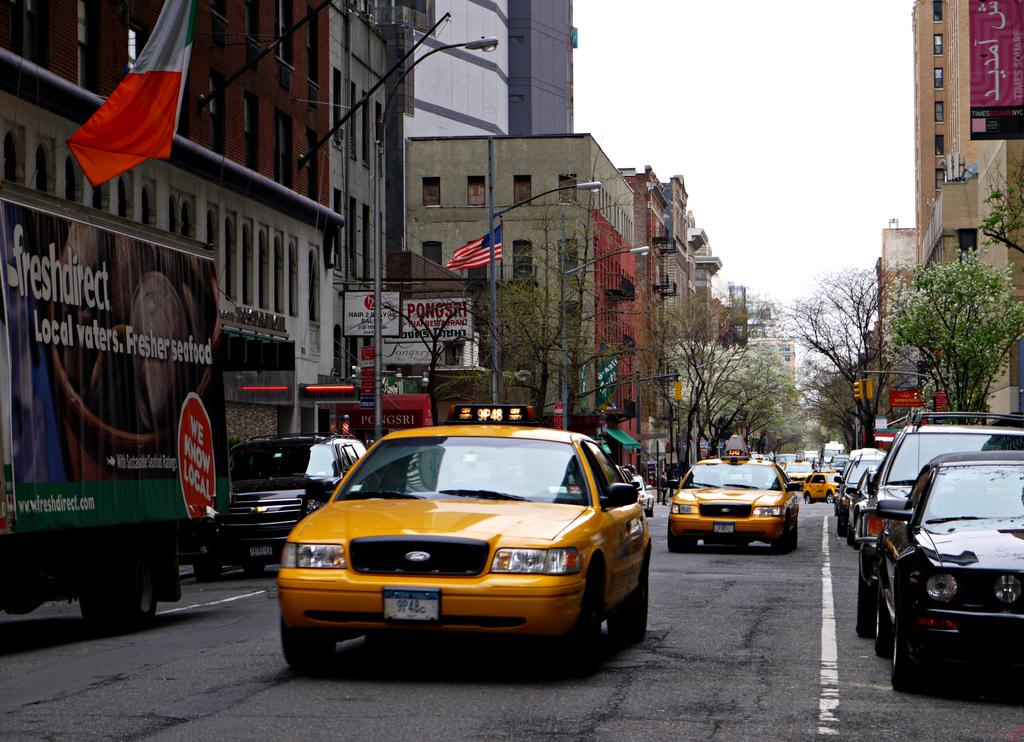<image>
Write a terse but informative summary of the picture. The yellow taxi drives next to a freshdirect truck. 